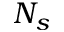Convert formula to latex. <formula><loc_0><loc_0><loc_500><loc_500>N _ { s }</formula> 